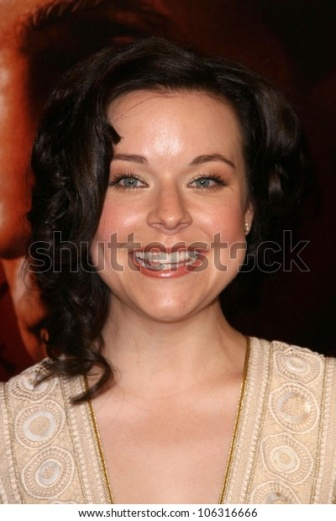What do you think the woman is thinking about? The woman in the image appears to be thinking about the joy and excitement of the event she's attending. Her smile suggests she's relishing the moment, possibly thinking about the hard work that led to this glamorous occasion or the people she might meet throughout the evening. She may also be reflecting on how fabulous she feels in her elegant attire. Write a poem about the image. Under the cascading curls, a smile so bright,
In a dress adorned with circular light,
She stands in elegance, a beacon this night,
Against the red backdrop, a joyous sight.

Earrings subtle, yet they gleam,
Completing the picture, a sparkling dream.
In a blur of crimson, a glamorous theme,
Her happiness radiates, like a sunbeam.

At the heart of the scene, she shines so clear,
A moment of wonder, a reason to cheer.
In a world of glamour, she's the one we revere,
Capturing hearts far and near. 